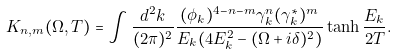Convert formula to latex. <formula><loc_0><loc_0><loc_500><loc_500>K _ { n , m } ( \Omega , T ) = \int \frac { d ^ { 2 } k } { ( 2 \pi ) ^ { 2 } } \frac { ( \phi _ { k } ) ^ { 4 - n - m } \gamma ^ { n } _ { k } ( \gamma ^ { * } _ { k } ) ^ { m } } { E _ { k } ( 4 E ^ { 2 } _ { k } - ( \Omega + i \delta ) ^ { 2 } ) } \tanh { \frac { E _ { k } } { 2 T } } .</formula> 